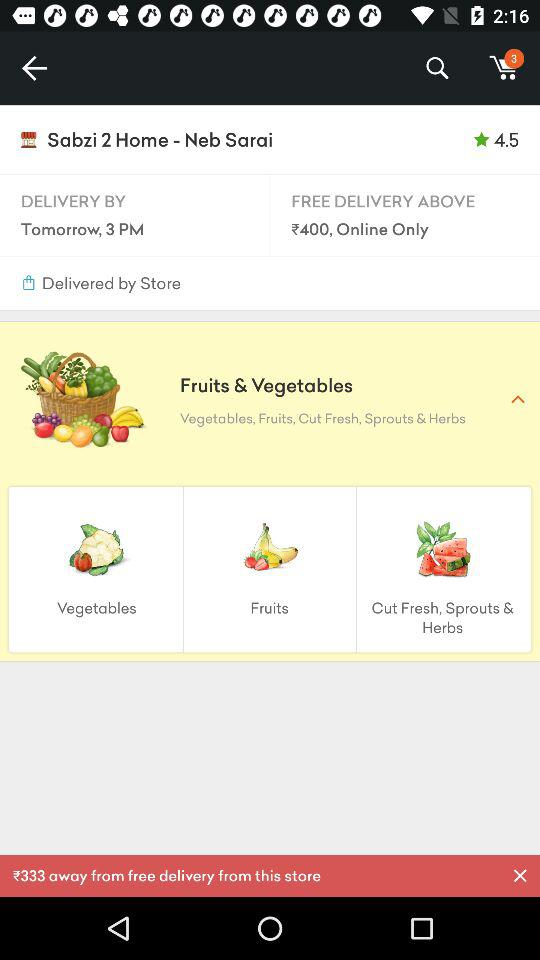How much more do I need to spend to get free delivery?
Answer the question using a single word or phrase. 333 